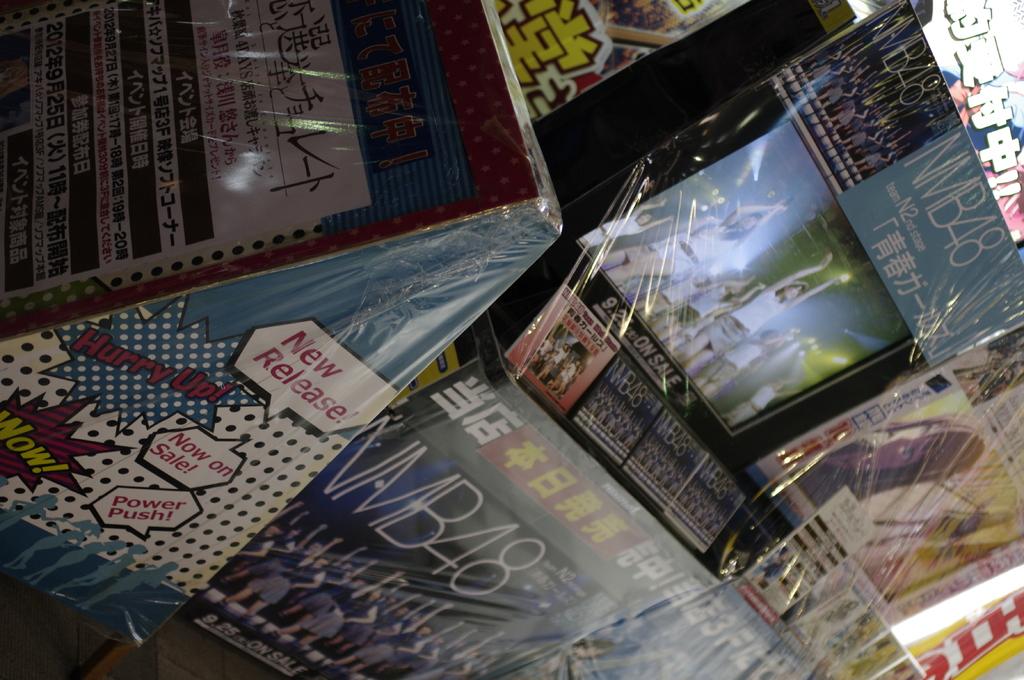What do the red words with polka dot background star say on the side of the case?
Your answer should be very brief. Hurry up!. On the side of the case, what does the top text bubble say?
Ensure brevity in your answer.  New release. 